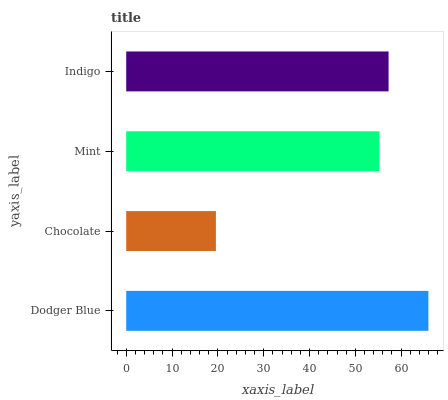Is Chocolate the minimum?
Answer yes or no. Yes. Is Dodger Blue the maximum?
Answer yes or no. Yes. Is Mint the minimum?
Answer yes or no. No. Is Mint the maximum?
Answer yes or no. No. Is Mint greater than Chocolate?
Answer yes or no. Yes. Is Chocolate less than Mint?
Answer yes or no. Yes. Is Chocolate greater than Mint?
Answer yes or no. No. Is Mint less than Chocolate?
Answer yes or no. No. Is Indigo the high median?
Answer yes or no. Yes. Is Mint the low median?
Answer yes or no. Yes. Is Mint the high median?
Answer yes or no. No. Is Indigo the low median?
Answer yes or no. No. 